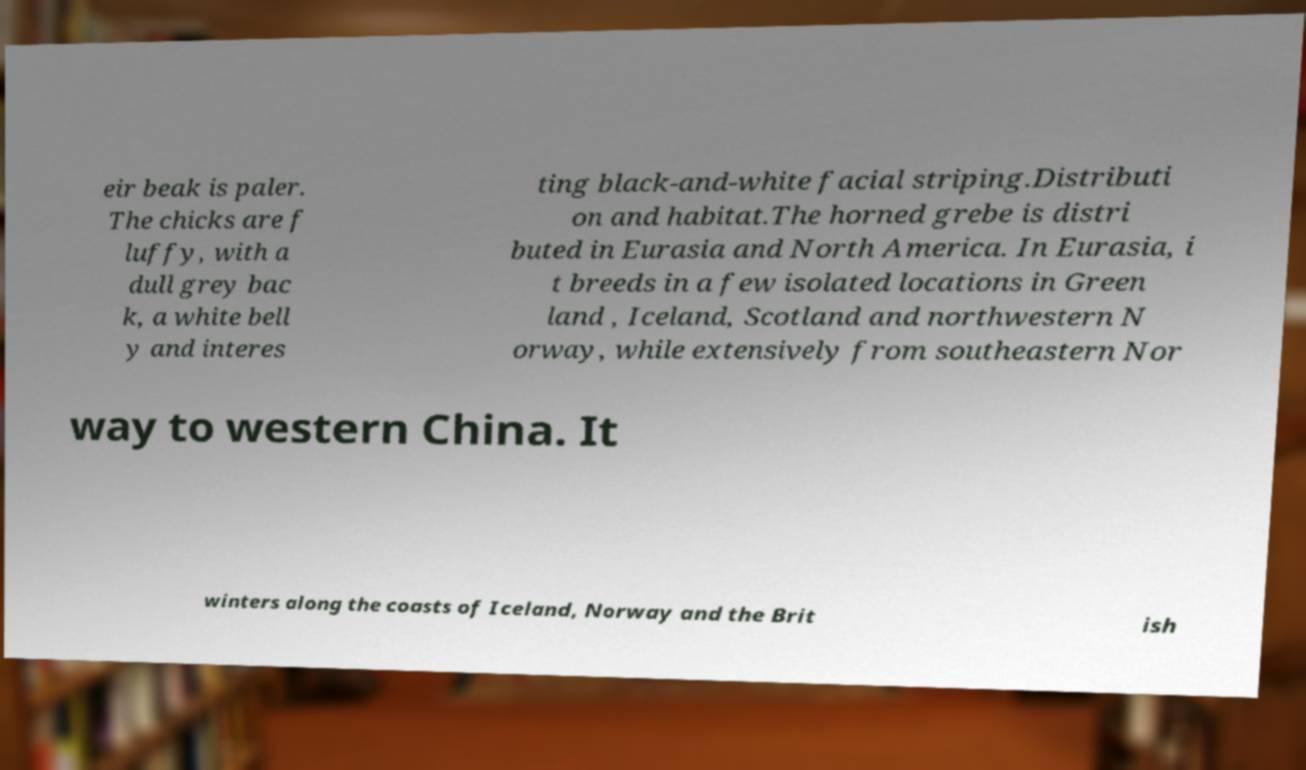For documentation purposes, I need the text within this image transcribed. Could you provide that? eir beak is paler. The chicks are f luffy, with a dull grey bac k, a white bell y and interes ting black-and-white facial striping.Distributi on and habitat.The horned grebe is distri buted in Eurasia and North America. In Eurasia, i t breeds in a few isolated locations in Green land , Iceland, Scotland and northwestern N orway, while extensively from southeastern Nor way to western China. It winters along the coasts of Iceland, Norway and the Brit ish 